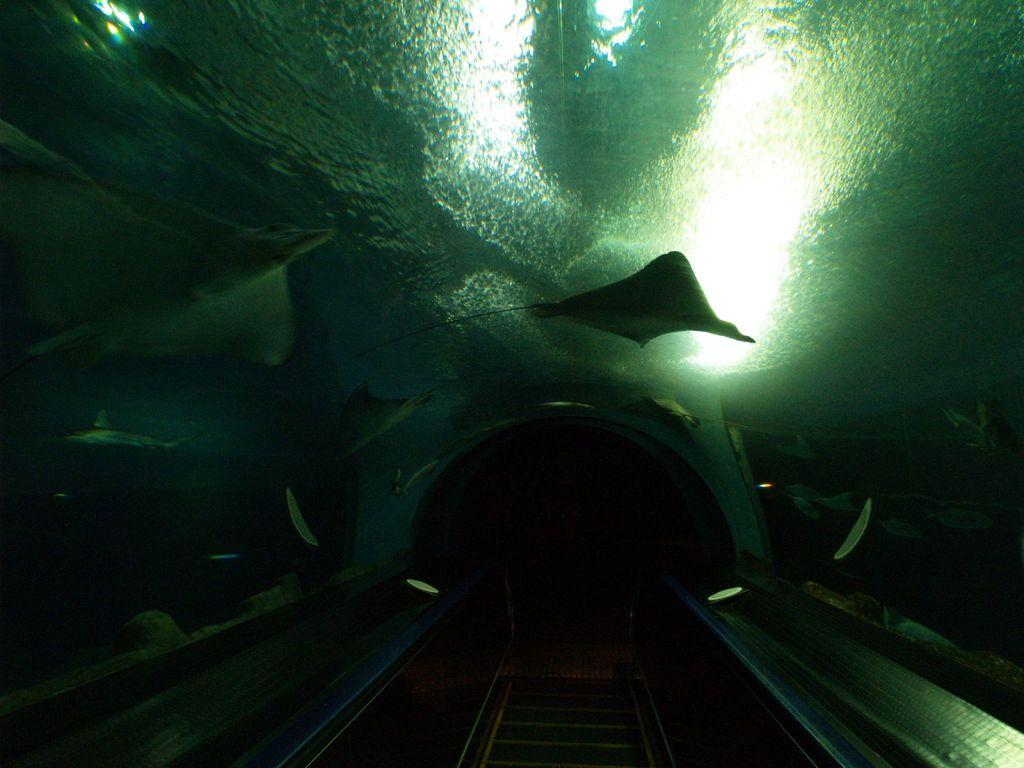What type of animals can be seen in the image? There are fishes in the image. What is the primary element in which the fishes are situated? There is water visible in the image. What architectural feature is present in the image? There is a railway track in the image. What time of day is it in the image, as indicated by the peace unit? There is no indication of time or any peace unit present in the image; it features fishes in water and a railway track. 